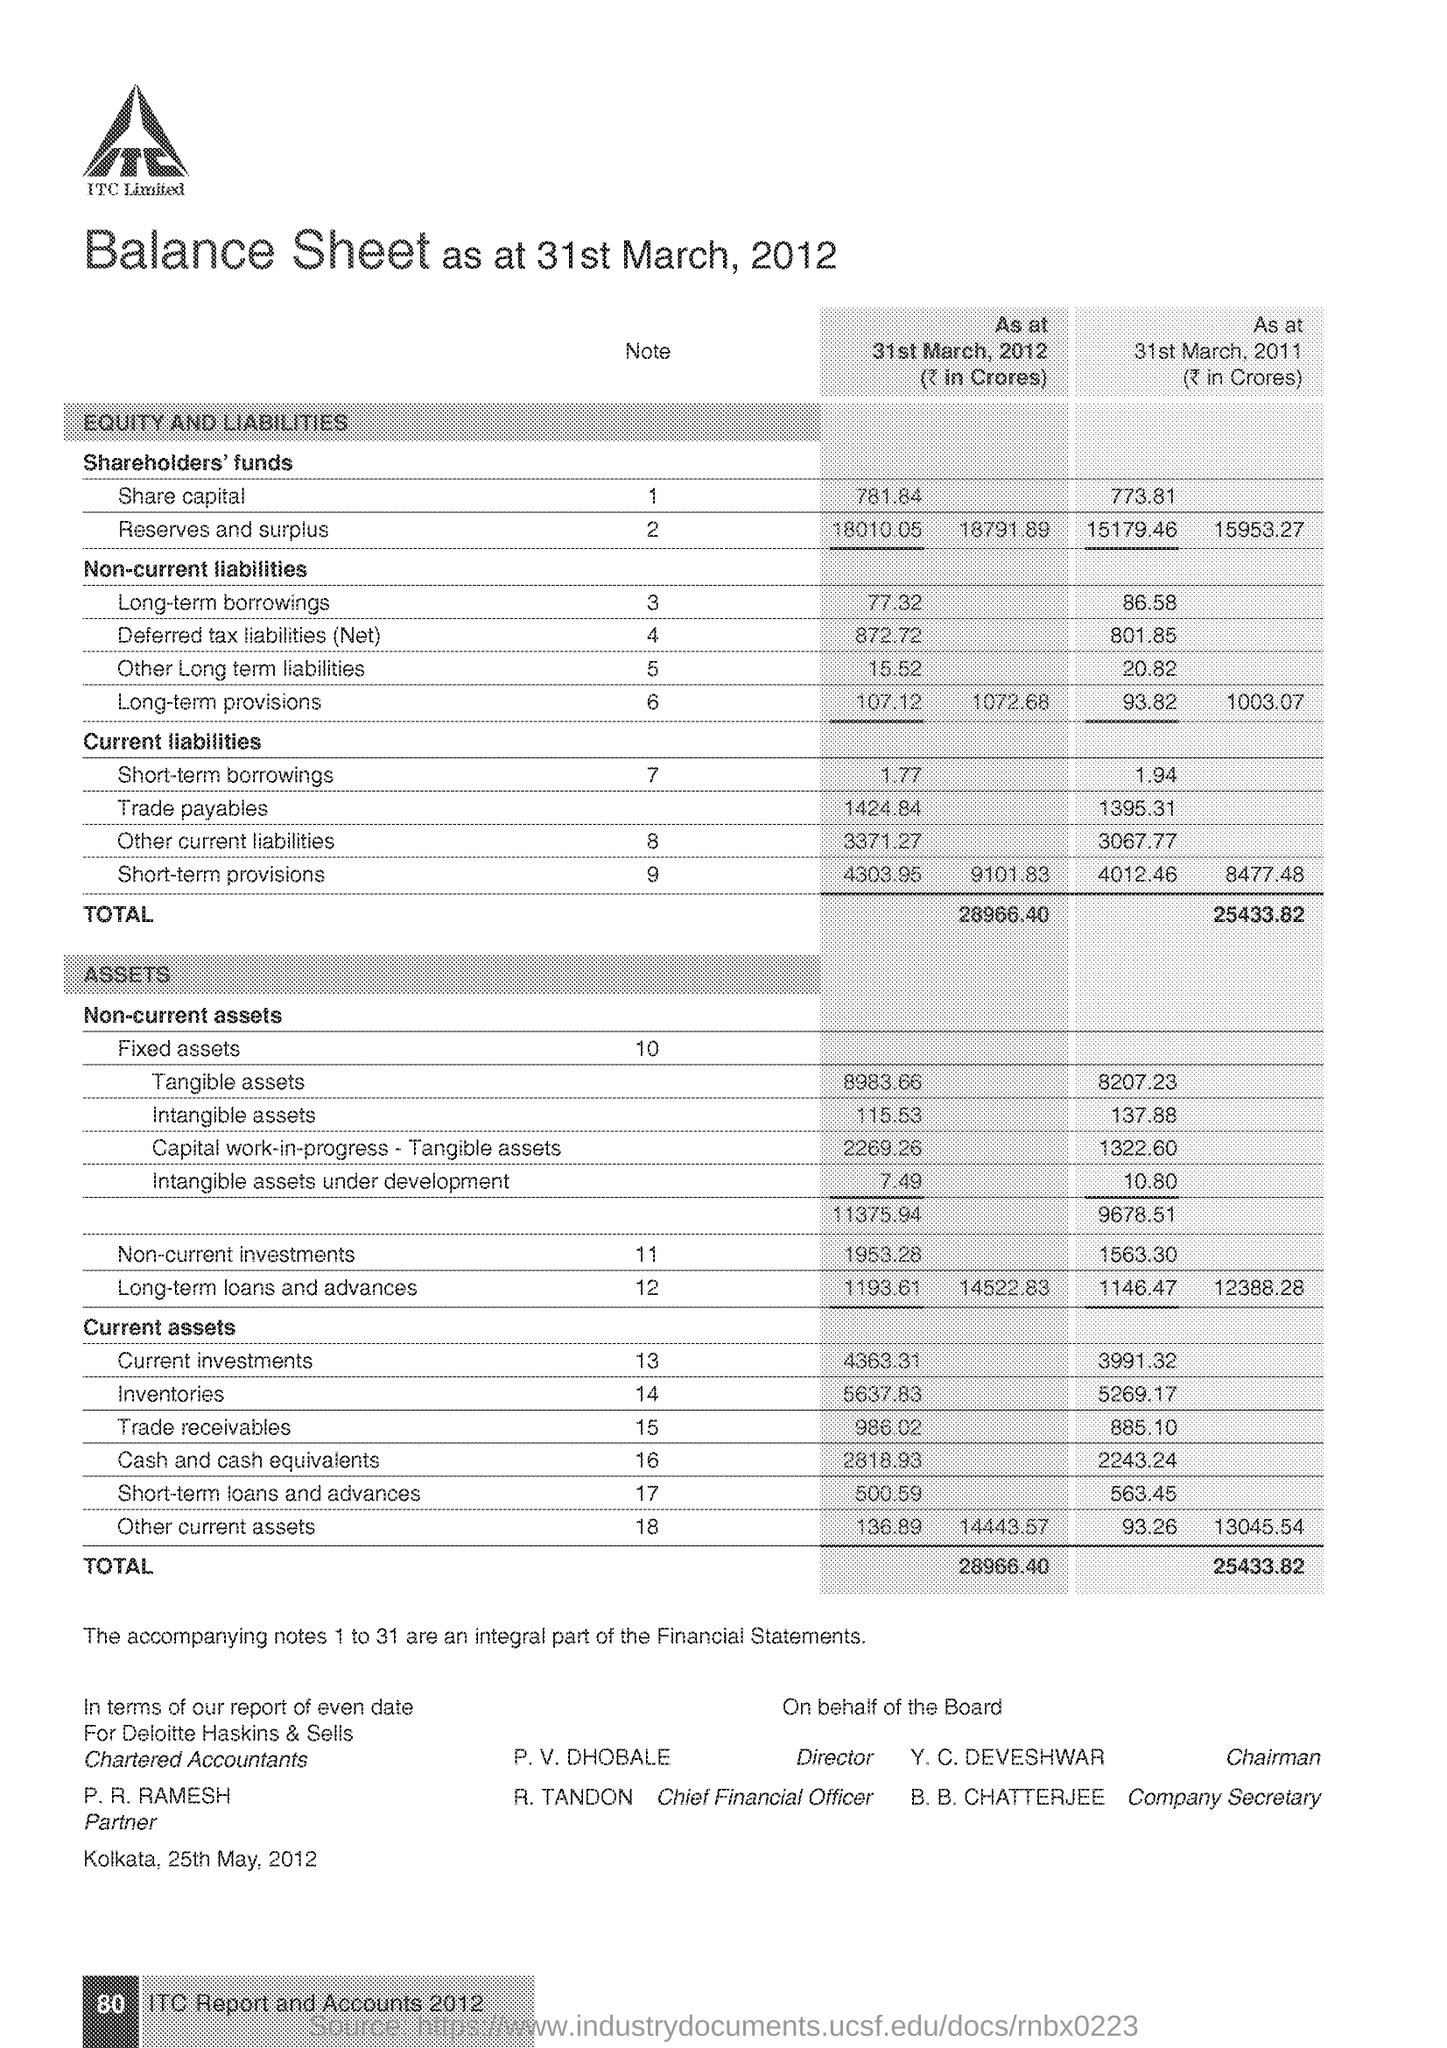List a handful of essential elements in this visual. In 2012, the company had a share capital of 781.84 The fixed asset note number is 10. The Chief Financial Officer is R. Tandon. The person named Y. C. DEVESHWAR is the Chairman. In 2011, the amount of Trade Payables was 1,395.31. 